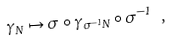<formula> <loc_0><loc_0><loc_500><loc_500>\gamma _ { N } \mapsto \sigma \circ \gamma _ { \sigma ^ { - 1 } N } \circ \sigma ^ { - 1 } \ ,</formula> 